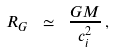<formula> <loc_0><loc_0><loc_500><loc_500>R _ { G } \ \simeq \ \frac { G M } { c _ { i } ^ { 2 } } \, ,</formula> 